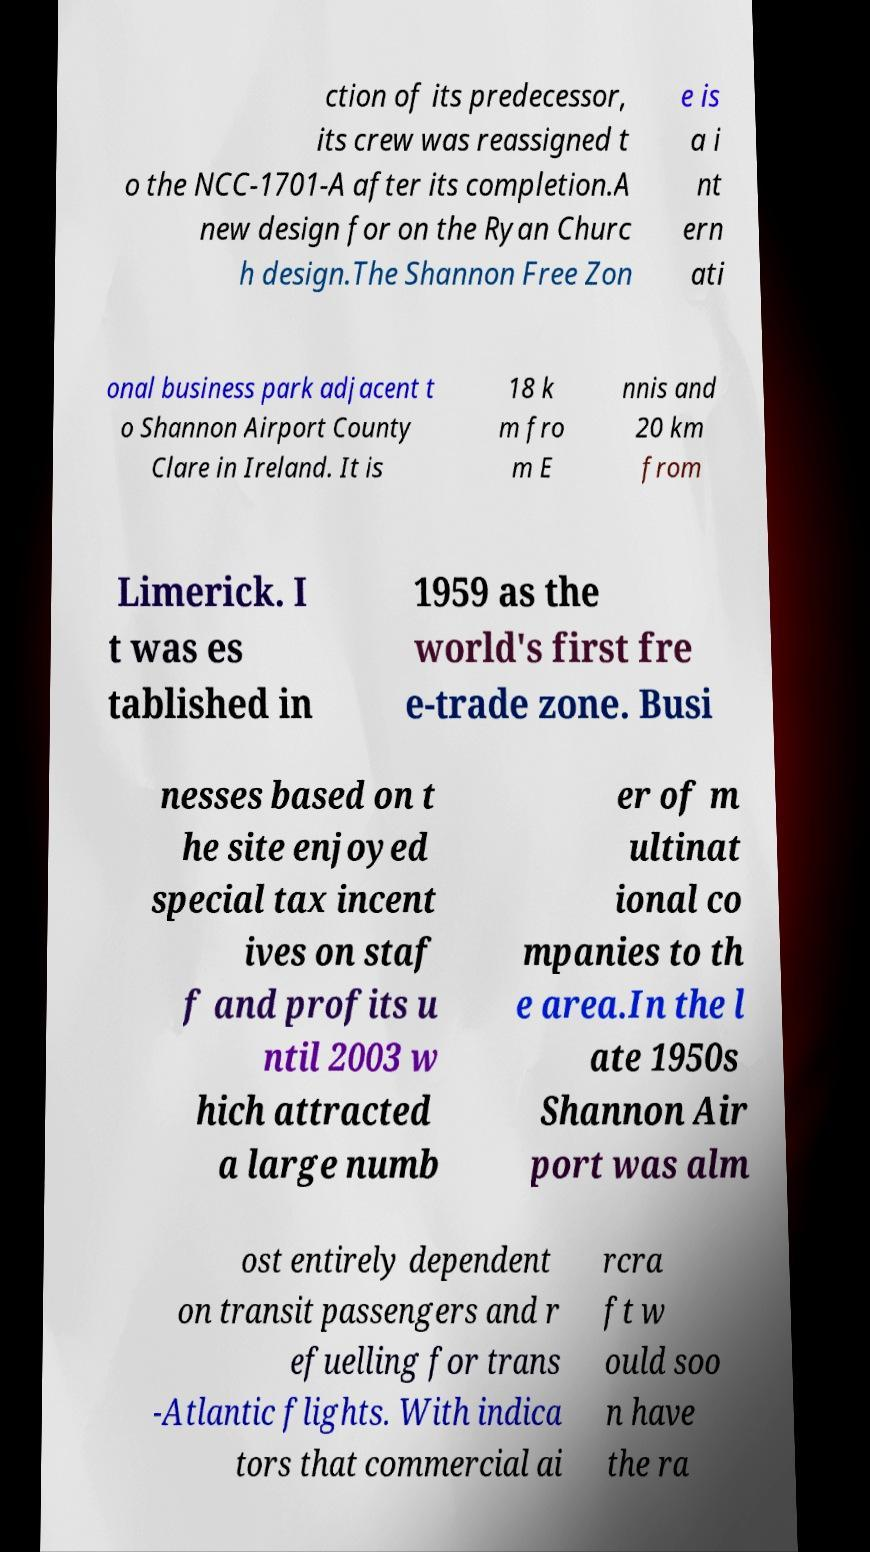What messages or text are displayed in this image? I need them in a readable, typed format. ction of its predecessor, its crew was reassigned t o the NCC-1701-A after its completion.A new design for on the Ryan Churc h design.The Shannon Free Zon e is a i nt ern ati onal business park adjacent t o Shannon Airport County Clare in Ireland. It is 18 k m fro m E nnis and 20 km from Limerick. I t was es tablished in 1959 as the world's first fre e-trade zone. Busi nesses based on t he site enjoyed special tax incent ives on staf f and profits u ntil 2003 w hich attracted a large numb er of m ultinat ional co mpanies to th e area.In the l ate 1950s Shannon Air port was alm ost entirely dependent on transit passengers and r efuelling for trans -Atlantic flights. With indica tors that commercial ai rcra ft w ould soo n have the ra 